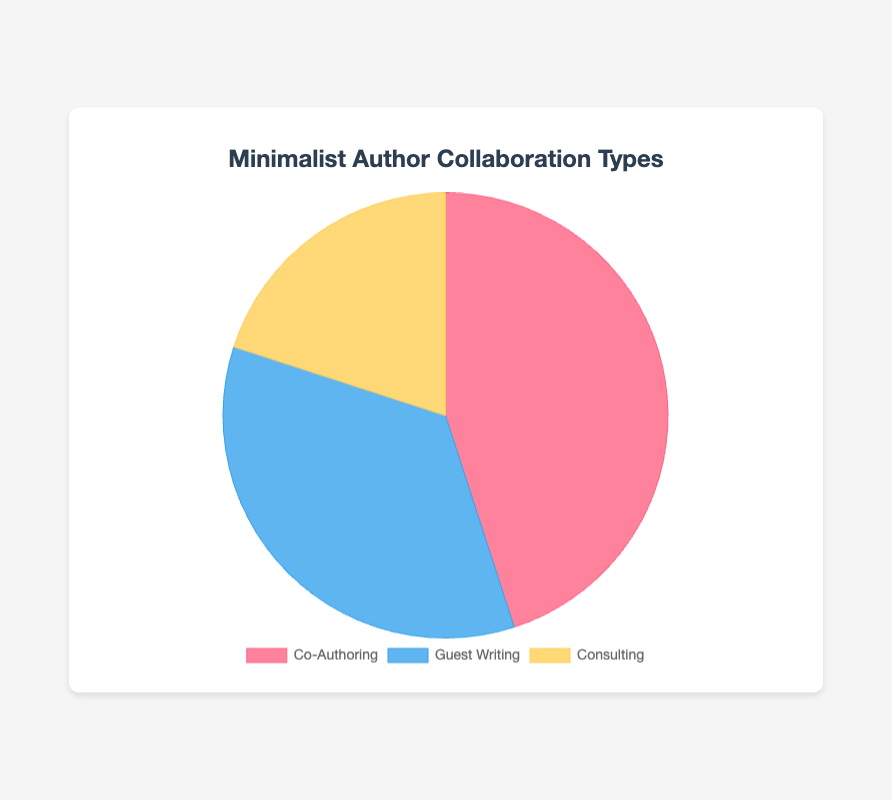What percentage of collaborations involve Consulting? The chart shows that the Consulting type covers 20% of the collaborations.
Answer: 20% Which type of collaboration is the most common? The chart indicates that Co-Authoring has the largest section, representing 45% of the collaborations.
Answer: Co-Authoring Which collaboration types together make up more than half of the total? Co-Authoring (45%) and Guest Writing (35%) together make up 80% of the chart, which is more than half.
Answer: Co-Authoring and Guest Writing What is the difference in percentage points between Co-Authoring and Consulting? Co-Authoring is 45% and Consulting is 20%, so the difference is 45% - 20% = 25%.
Answer: 25% Which collaboration type has the smallest percentage? Consulting, representing 20%, is the smallest section.
Answer: Consulting What is the sum of the percentages for Guest Writing and Consulting? Guest Writing is 35% and Consulting is 20%, so the sum is 35% + 20% = 55%.
Answer: 55% Which section of the pie chart is represented in blue? The blue section corresponds to Guest Writing.
Answer: Guest Writing If the percentage for Co-Authoring were to increase by 10 percentage points, what would its new percentage be? Currently, Co-Authoring is at 45%. Increasing by 10 percentage points: 45% + 10% = 55%.
Answer: 55% How much more common is Guest Writing compared to Consulting? Guest Writing is 35% and Consulting is 20%. The difference is 35% - 20% = 15%.
Answer: 15% 